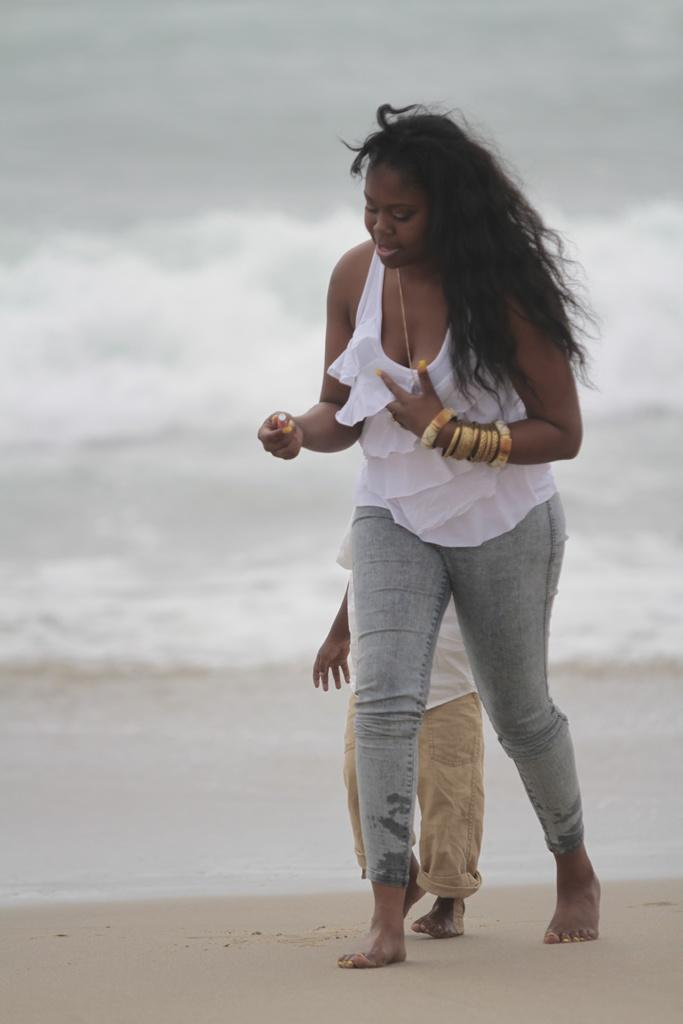What is the main subject of the image? The main subject of the image is a woman walking. What is the woman walking on? The woman is walking on land. Is there anyone else in the image? Yes, there is a kid walking behind the woman. What can be seen in the background of the image? The background of the image includes water with tides. What type of tramp can be seen in the image? There is no tramp present in the image. Can you tell me how many sticks the woman is carrying in the image? There are no sticks visible in the image. 